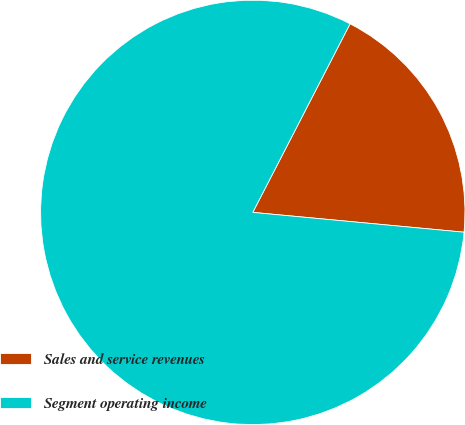<chart> <loc_0><loc_0><loc_500><loc_500><pie_chart><fcel>Sales and service revenues<fcel>Segment operating income<nl><fcel>18.91%<fcel>81.09%<nl></chart> 